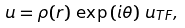<formula> <loc_0><loc_0><loc_500><loc_500>u = \rho ( r ) \, \exp \left ( i \theta \right ) \, u _ { T F } ,</formula> 